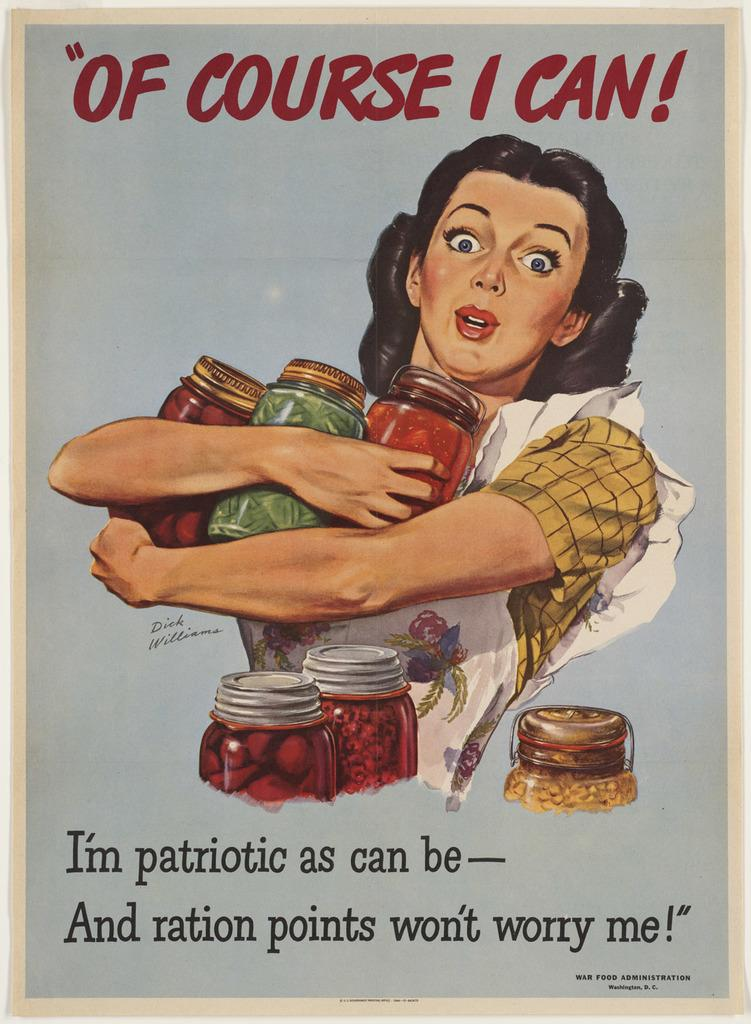<image>
Give a short and clear explanation of the subsequent image. A woman proudly holds her jars of home canned produce, while saying, "Of course I can!" 